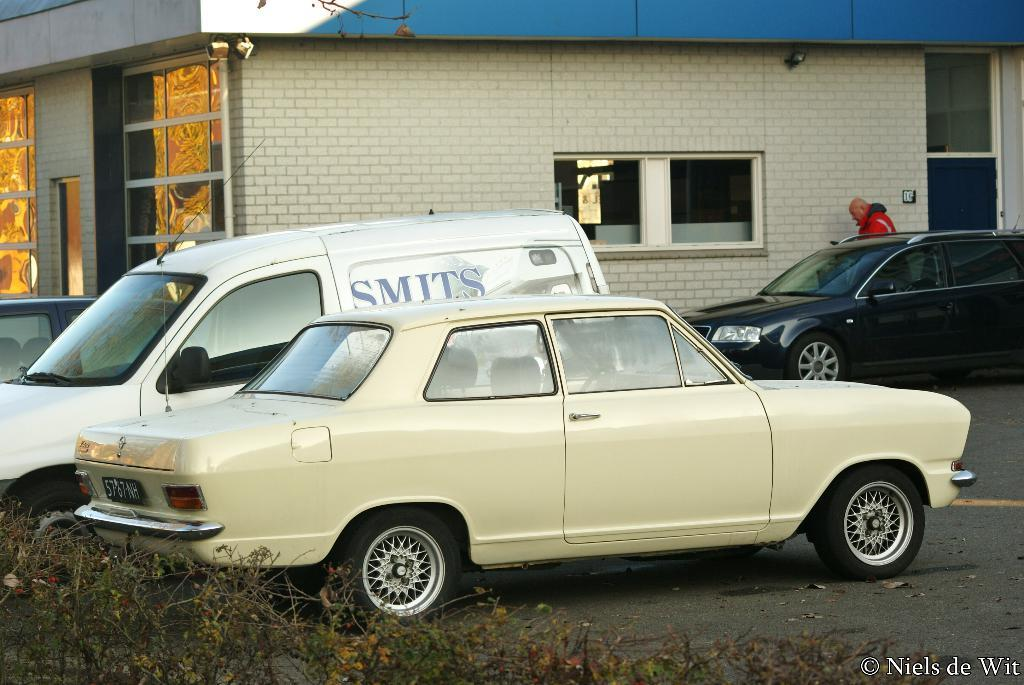What can be seen on the road in the image? There are vehicles on the road in the image. Where is the man located in the image? The man is standing near a wall in the image. What is visible in the background of the image? There is a building with windows in the background of the image. How many vases are on the wall in the image? There are no vases present in the image. What is the distance between the man and the building in the image? The provided facts do not give information about the distance between the man and the building, so it cannot be determined from the image. 